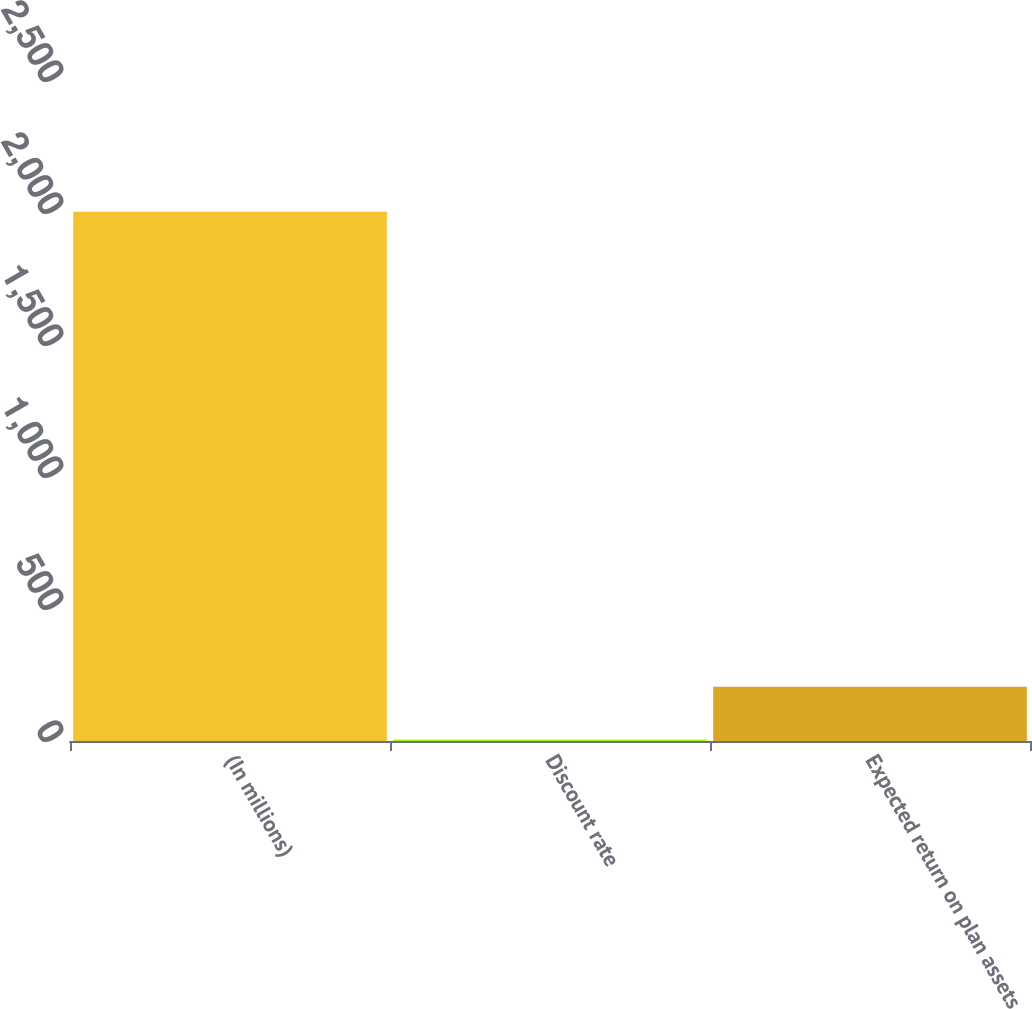Convert chart. <chart><loc_0><loc_0><loc_500><loc_500><bar_chart><fcel>(In millions)<fcel>Discount rate<fcel>Expected return on plan assets<nl><fcel>2005<fcel>5.9<fcel>205.81<nl></chart> 